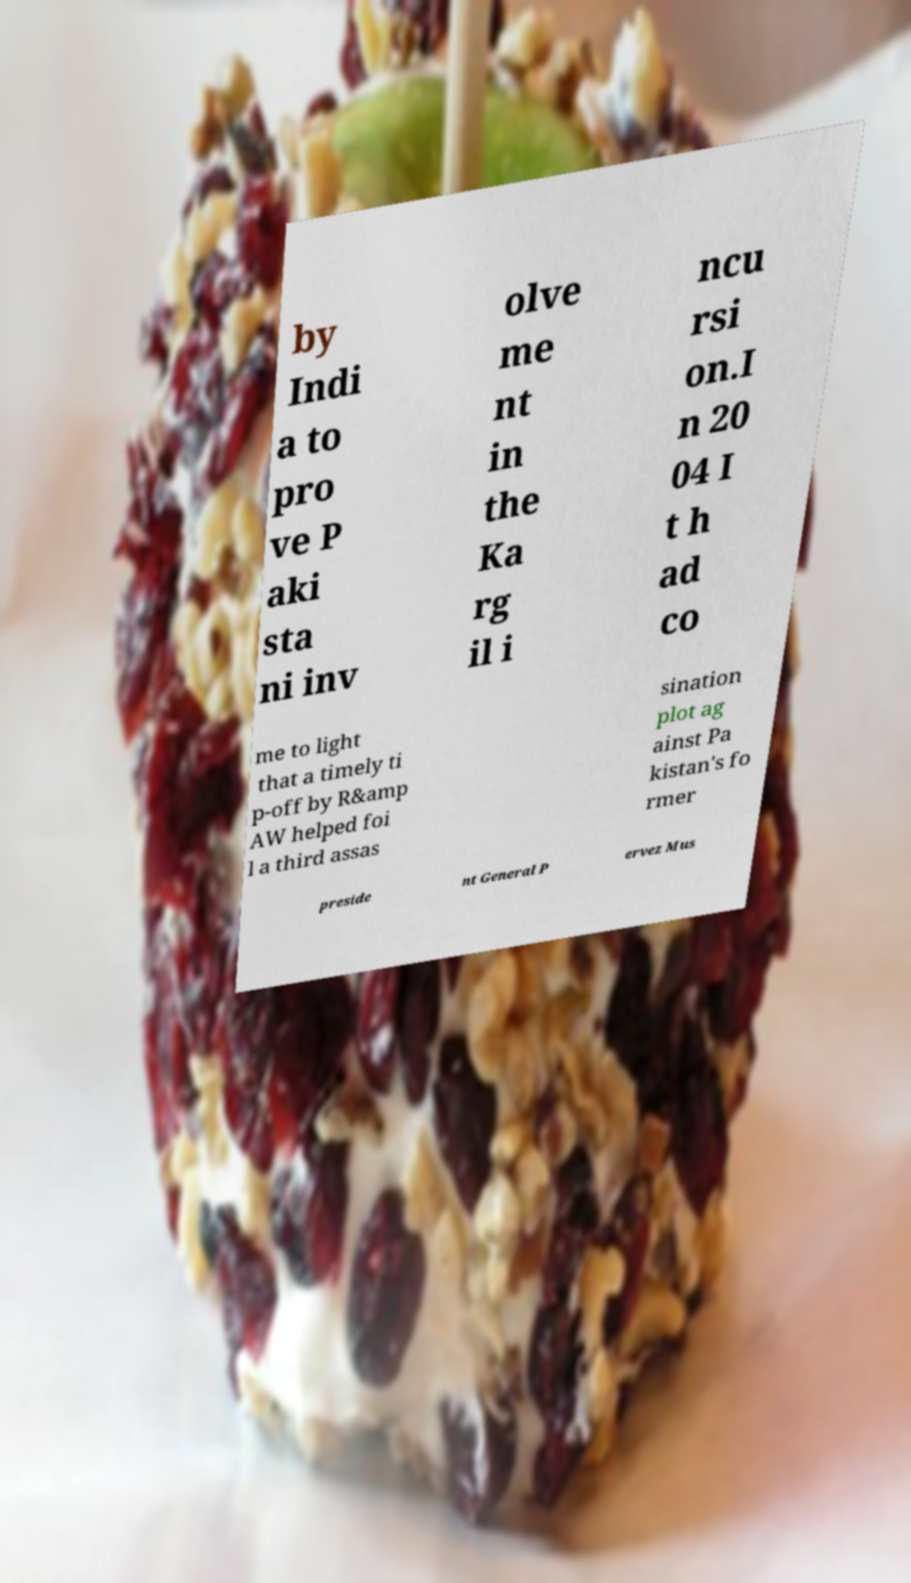Please identify and transcribe the text found in this image. by Indi a to pro ve P aki sta ni inv olve me nt in the Ka rg il i ncu rsi on.I n 20 04 I t h ad co me to light that a timely ti p-off by R&amp AW helped foi l a third assas sination plot ag ainst Pa kistan's fo rmer preside nt General P ervez Mus 